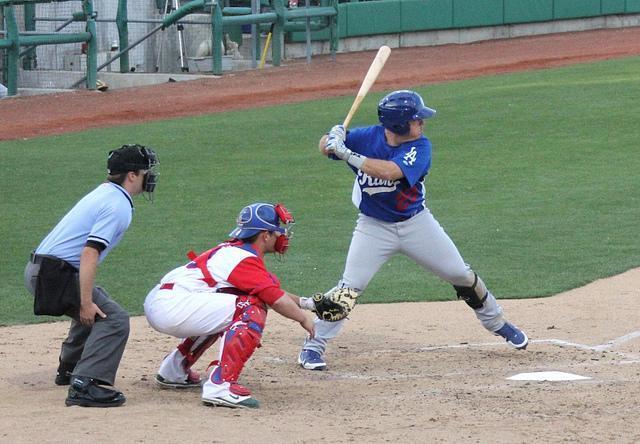How many people are visible?
Give a very brief answer. 3. 